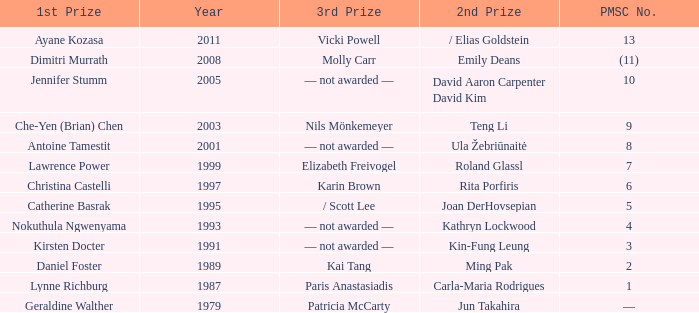What is the earliest year in which the 1st price went to Che-Yen (Brian) Chen? 2003.0. 